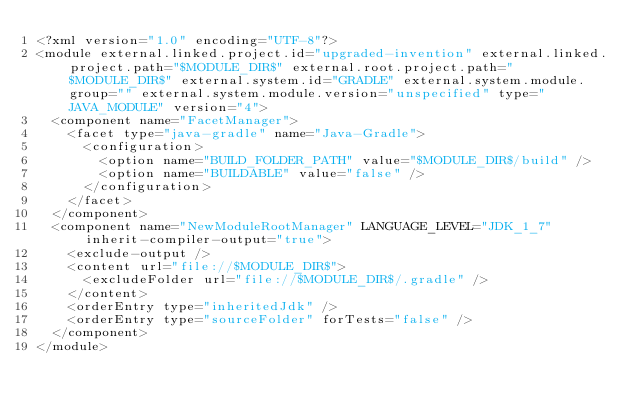<code> <loc_0><loc_0><loc_500><loc_500><_XML_><?xml version="1.0" encoding="UTF-8"?>
<module external.linked.project.id="upgraded-invention" external.linked.project.path="$MODULE_DIR$" external.root.project.path="$MODULE_DIR$" external.system.id="GRADLE" external.system.module.group="" external.system.module.version="unspecified" type="JAVA_MODULE" version="4">
  <component name="FacetManager">
    <facet type="java-gradle" name="Java-Gradle">
      <configuration>
        <option name="BUILD_FOLDER_PATH" value="$MODULE_DIR$/build" />
        <option name="BUILDABLE" value="false" />
      </configuration>
    </facet>
  </component>
  <component name="NewModuleRootManager" LANGUAGE_LEVEL="JDK_1_7" inherit-compiler-output="true">
    <exclude-output />
    <content url="file://$MODULE_DIR$">
      <excludeFolder url="file://$MODULE_DIR$/.gradle" />
    </content>
    <orderEntry type="inheritedJdk" />
    <orderEntry type="sourceFolder" forTests="false" />
  </component>
</module></code> 